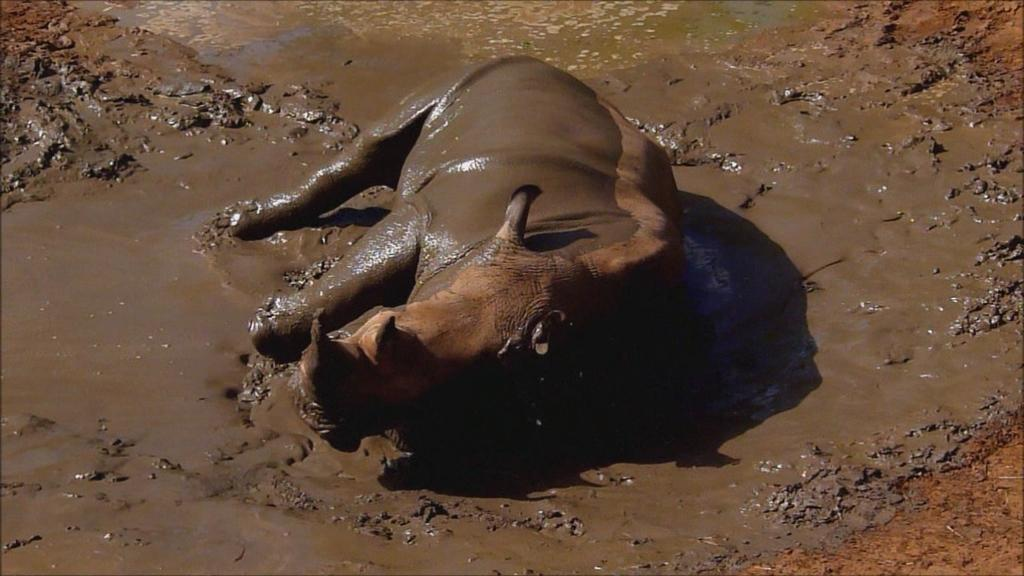What animal is present in the image? There is a Hippopotamus in the image. What is the Hippopotamus doing in the image? The Hippopotamus is laying on the mud floor. How many cows are present in the image? There are no cows present in the image; it features a Hippopotamus. What type of quiet environment is the Hippopotamus in? The image does not provide information about the noise level or environment surrounding the Hippopotamus. 